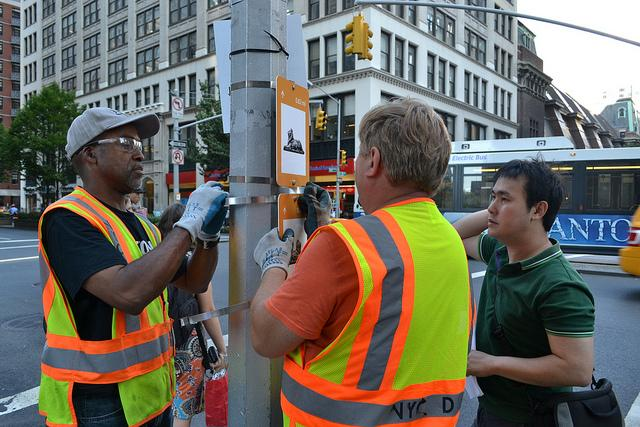What are the signs for? information 